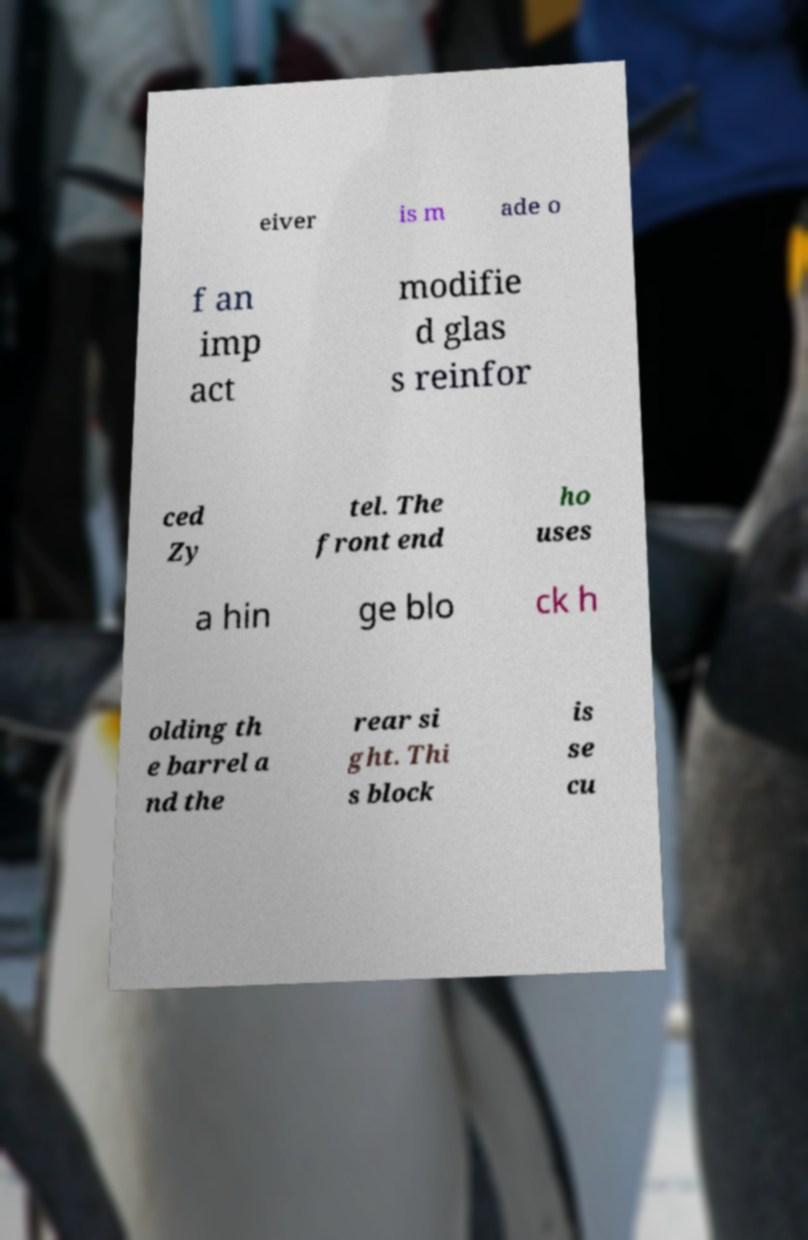I need the written content from this picture converted into text. Can you do that? eiver is m ade o f an imp act modifie d glas s reinfor ced Zy tel. The front end ho uses a hin ge blo ck h olding th e barrel a nd the rear si ght. Thi s block is se cu 